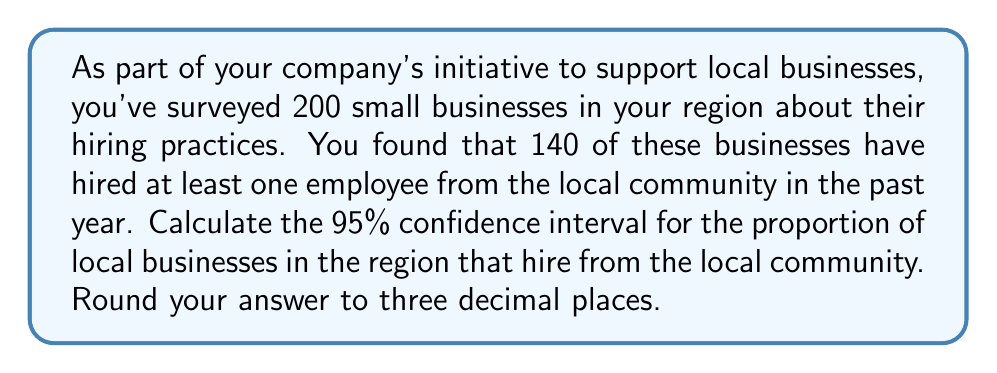Help me with this question. Let's approach this step-by-step:

1) First, we need to calculate the sample proportion:
   $\hat{p} = \frac{\text{number of successes}}{\text{sample size}} = \frac{140}{200} = 0.7$

2) The formula for the confidence interval is:
   $$\hat{p} \pm z^* \sqrt{\frac{\hat{p}(1-\hat{p})}{n}}$$
   where $z^*$ is the critical value for the desired confidence level.

3) For a 95% confidence interval, $z^* = 1.96$

4) Now, let's substitute our values:
   $n = 200$
   $\hat{p} = 0.7$

5) Calculate the standard error:
   $$SE = \sqrt{\frac{\hat{p}(1-\hat{p})}{n}} = \sqrt{\frac{0.7(1-0.7)}{200}} = \sqrt{\frac{0.21}{200}} = 0.0324$$

6) Now we can calculate the margin of error:
   $$ME = z^* \cdot SE = 1.96 \cdot 0.0324 = 0.0635$$

7) Finally, we can calculate the confidence interval:
   Lower bound: $0.7 - 0.0635 = 0.6365$
   Upper bound: $0.7 + 0.0635 = 0.7635$

8) Rounding to three decimal places:
   (0.637, 0.764)
Answer: (0.637, 0.764) 